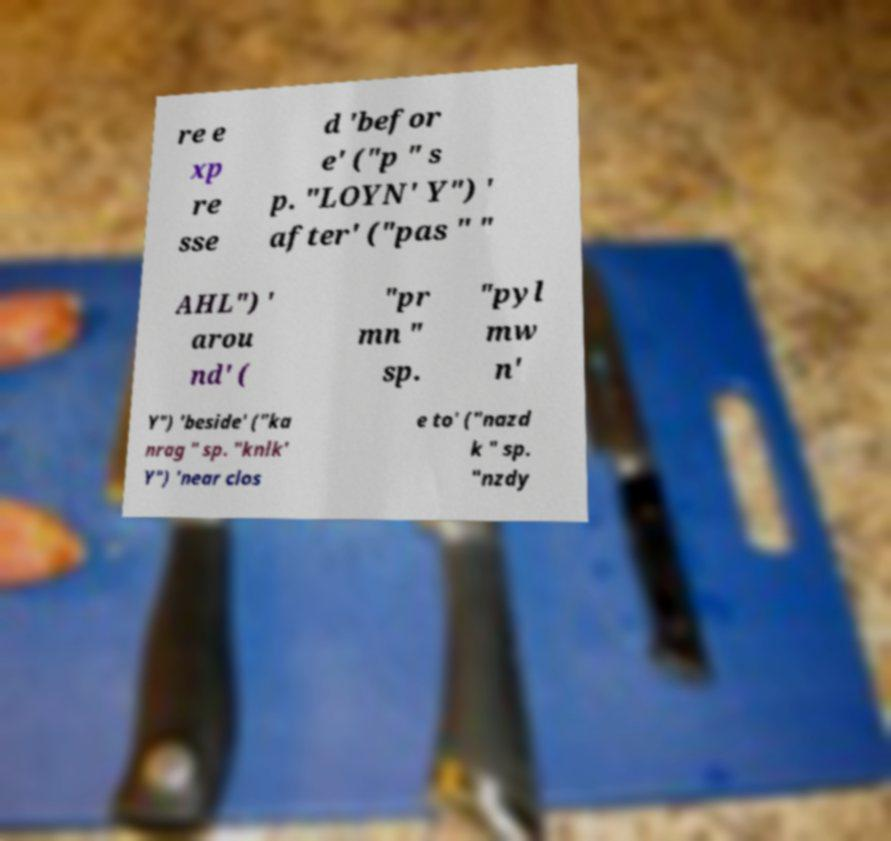What messages or text are displayed in this image? I need them in a readable, typed format. re e xp re sse d 'befor e' ("p " s p. "LOYN' Y") ' after' ("pas " " AHL") ' arou nd' ( "pr mn " sp. "pyl mw n' Y") 'beside' ("ka nrag " sp. "knlk' Y") 'near clos e to' ("nazd k " sp. "nzdy 